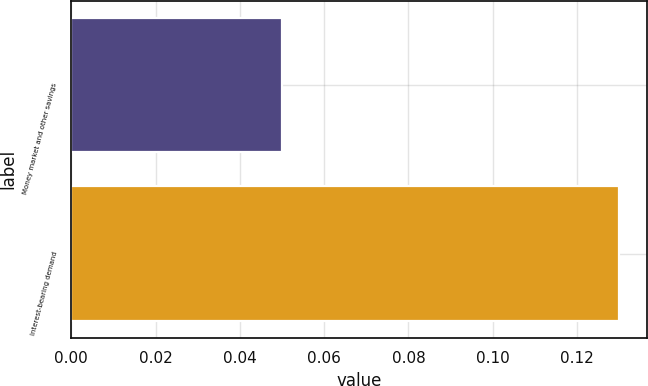Convert chart to OTSL. <chart><loc_0><loc_0><loc_500><loc_500><bar_chart><fcel>Money market and other savings<fcel>Interest-bearing demand<nl><fcel>0.05<fcel>0.13<nl></chart> 